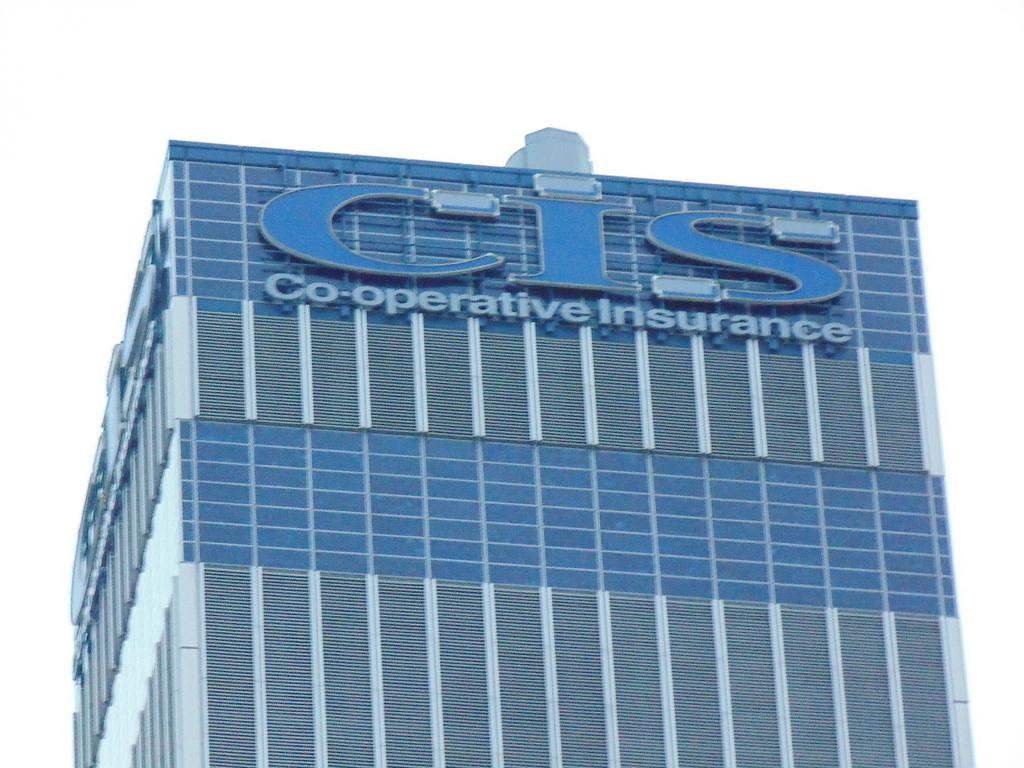What type of structure is visible in the image? There is a building in the image. What colors are used on the building? The building has gray and blue colors. What color is the background of the image? The background of the image is white. Where is the salt container located in the image? There is no salt container present in the image. What type of pail is being used to carry the building in the image? There is no pail or any indication of carrying the building in the image. 